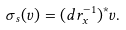<formula> <loc_0><loc_0><loc_500><loc_500>\sigma _ { s } ( v ) = ( d r _ { x } ^ { - 1 } ) ^ { * } v .</formula> 